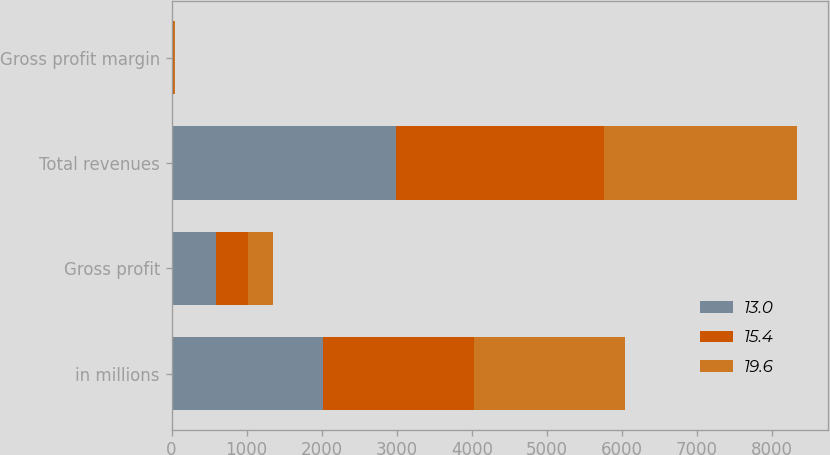Convert chart. <chart><loc_0><loc_0><loc_500><loc_500><stacked_bar_chart><ecel><fcel>in millions<fcel>Gross profit<fcel>Total revenues<fcel>Gross profit margin<nl><fcel>13<fcel>2014<fcel>587.6<fcel>2994.2<fcel>19.6<nl><fcel>15.4<fcel>2013<fcel>426.9<fcel>2770.7<fcel>15.4<nl><fcel>19.6<fcel>2012<fcel>334<fcel>2567.3<fcel>13<nl></chart> 